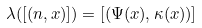<formula> <loc_0><loc_0><loc_500><loc_500>\lambda ( [ ( n , x ) ] ) = [ ( \Psi ( x ) , \kappa ( x ) ) ]</formula> 